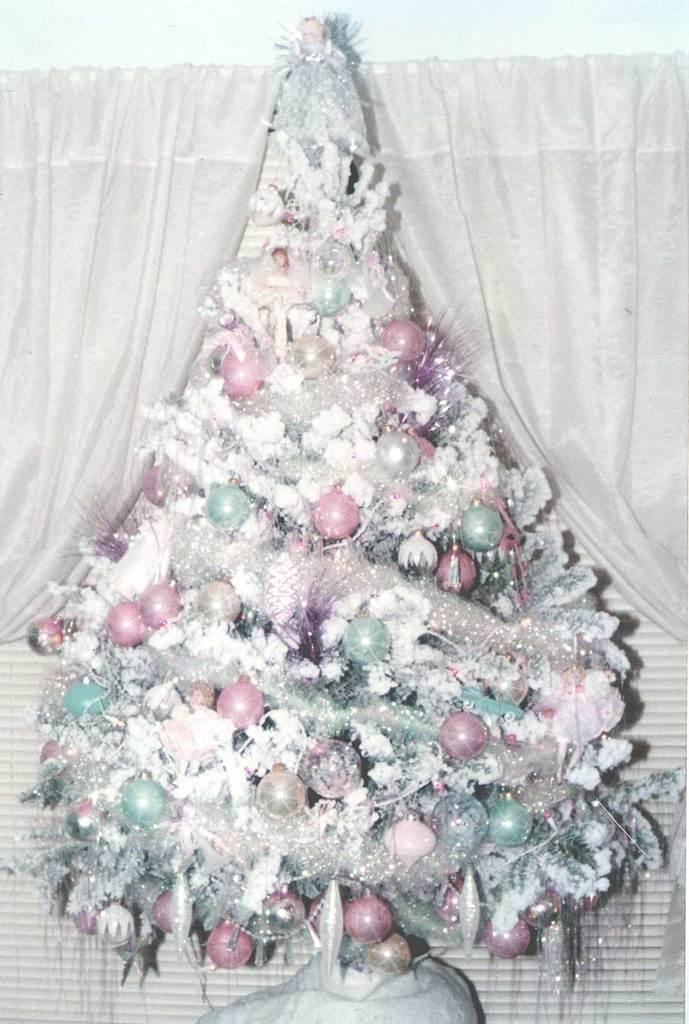What type of tree is in the image? There is a Christmas tree in the image. What can be seen on the Christmas tree? The Christmas tree has decorative items. What type of window treatment is present in the image? There are curtains in the image. What type of structure is visible in the image? There is a wall visible in the image. What type of road can be seen in the image? There is no road present in the image; it features a Christmas tree with decorative items, curtains, and a wall. How many weeks does the Christmas tree stay up in the image? The image does not provide information about the duration of the Christmas tree's display. 